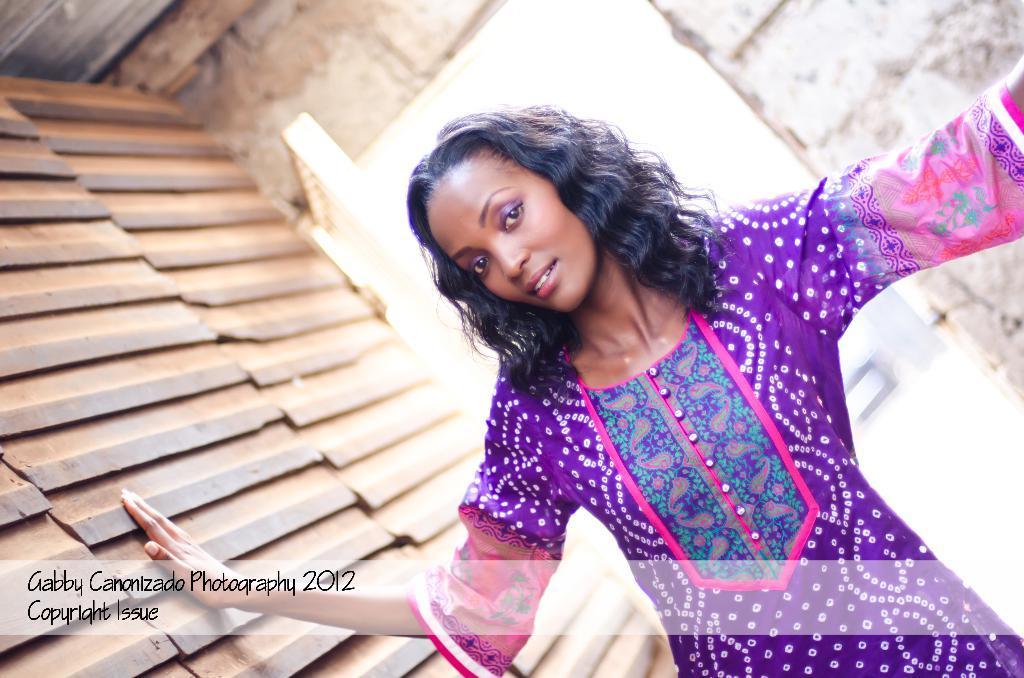Could you give a brief overview of what you see in this image? In this picture we can see a woman and we can see a wall in the background, in the bottom left we can see some text on it. 